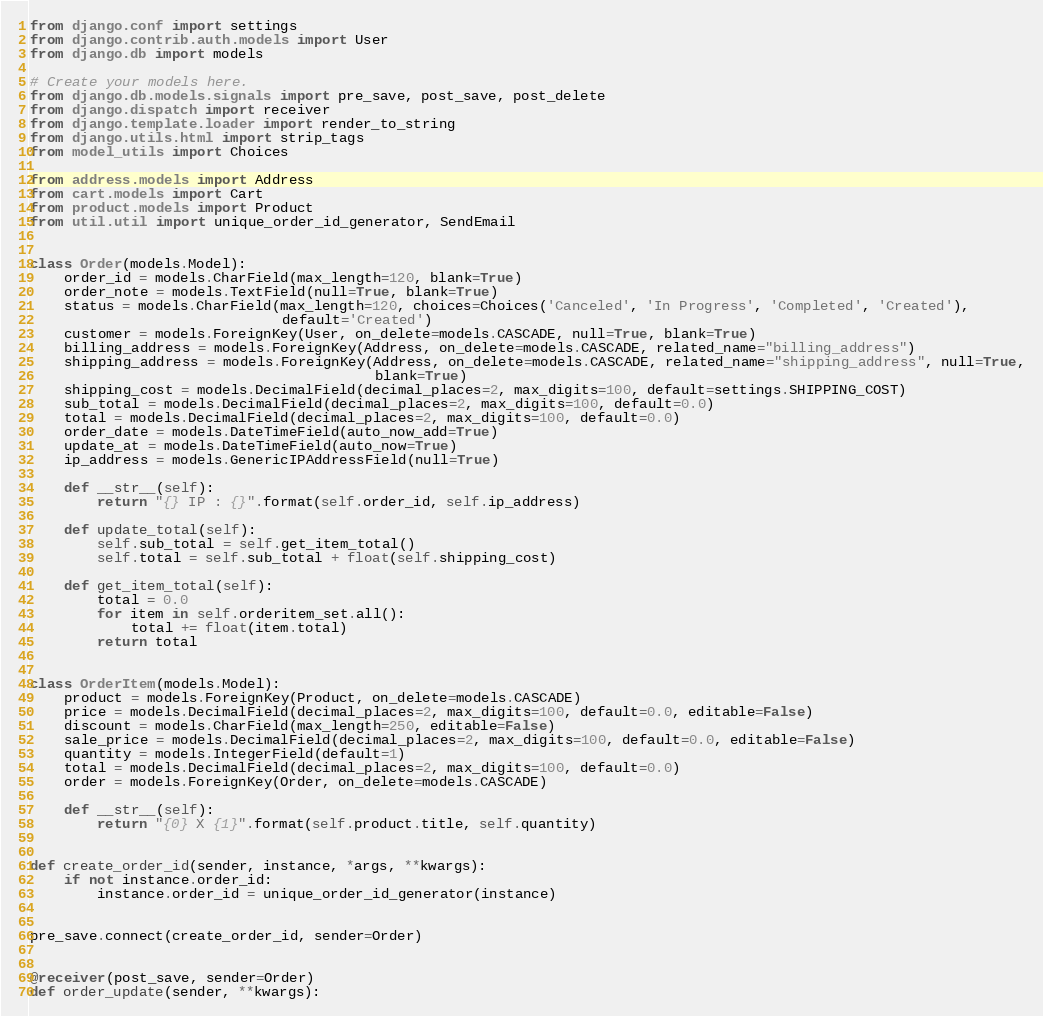Convert code to text. <code><loc_0><loc_0><loc_500><loc_500><_Python_>from django.conf import settings
from django.contrib.auth.models import User
from django.db import models

# Create your models here.
from django.db.models.signals import pre_save, post_save, post_delete
from django.dispatch import receiver
from django.template.loader import render_to_string
from django.utils.html import strip_tags
from model_utils import Choices

from address.models import Address
from cart.models import Cart
from product.models import Product
from util.util import unique_order_id_generator, SendEmail


class Order(models.Model):
    order_id = models.CharField(max_length=120, blank=True)
    order_note = models.TextField(null=True, blank=True)
    status = models.CharField(max_length=120, choices=Choices('Canceled', 'In Progress', 'Completed', 'Created'),
                              default='Created')
    customer = models.ForeignKey(User, on_delete=models.CASCADE, null=True, blank=True)
    billing_address = models.ForeignKey(Address, on_delete=models.CASCADE, related_name="billing_address")
    shipping_address = models.ForeignKey(Address, on_delete=models.CASCADE, related_name="shipping_address", null=True,
                                         blank=True)
    shipping_cost = models.DecimalField(decimal_places=2, max_digits=100, default=settings.SHIPPING_COST)
    sub_total = models.DecimalField(decimal_places=2, max_digits=100, default=0.0)
    total = models.DecimalField(decimal_places=2, max_digits=100, default=0.0)
    order_date = models.DateTimeField(auto_now_add=True)
    update_at = models.DateTimeField(auto_now=True)
    ip_address = models.GenericIPAddressField(null=True)

    def __str__(self):
        return "{} IP : {}".format(self.order_id, self.ip_address)

    def update_total(self):
        self.sub_total = self.get_item_total()
        self.total = self.sub_total + float(self.shipping_cost)

    def get_item_total(self):
        total = 0.0
        for item in self.orderitem_set.all():
            total += float(item.total)
        return total


class OrderItem(models.Model):
    product = models.ForeignKey(Product, on_delete=models.CASCADE)
    price = models.DecimalField(decimal_places=2, max_digits=100, default=0.0, editable=False)
    discount = models.CharField(max_length=250, editable=False)
    sale_price = models.DecimalField(decimal_places=2, max_digits=100, default=0.0, editable=False)
    quantity = models.IntegerField(default=1)
    total = models.DecimalField(decimal_places=2, max_digits=100, default=0.0)
    order = models.ForeignKey(Order, on_delete=models.CASCADE)

    def __str__(self):
        return "{0} X {1}".format(self.product.title, self.quantity)


def create_order_id(sender, instance, *args, **kwargs):
    if not instance.order_id:
        instance.order_id = unique_order_id_generator(instance)


pre_save.connect(create_order_id, sender=Order)


@receiver(post_save, sender=Order)
def order_update(sender, **kwargs):</code> 